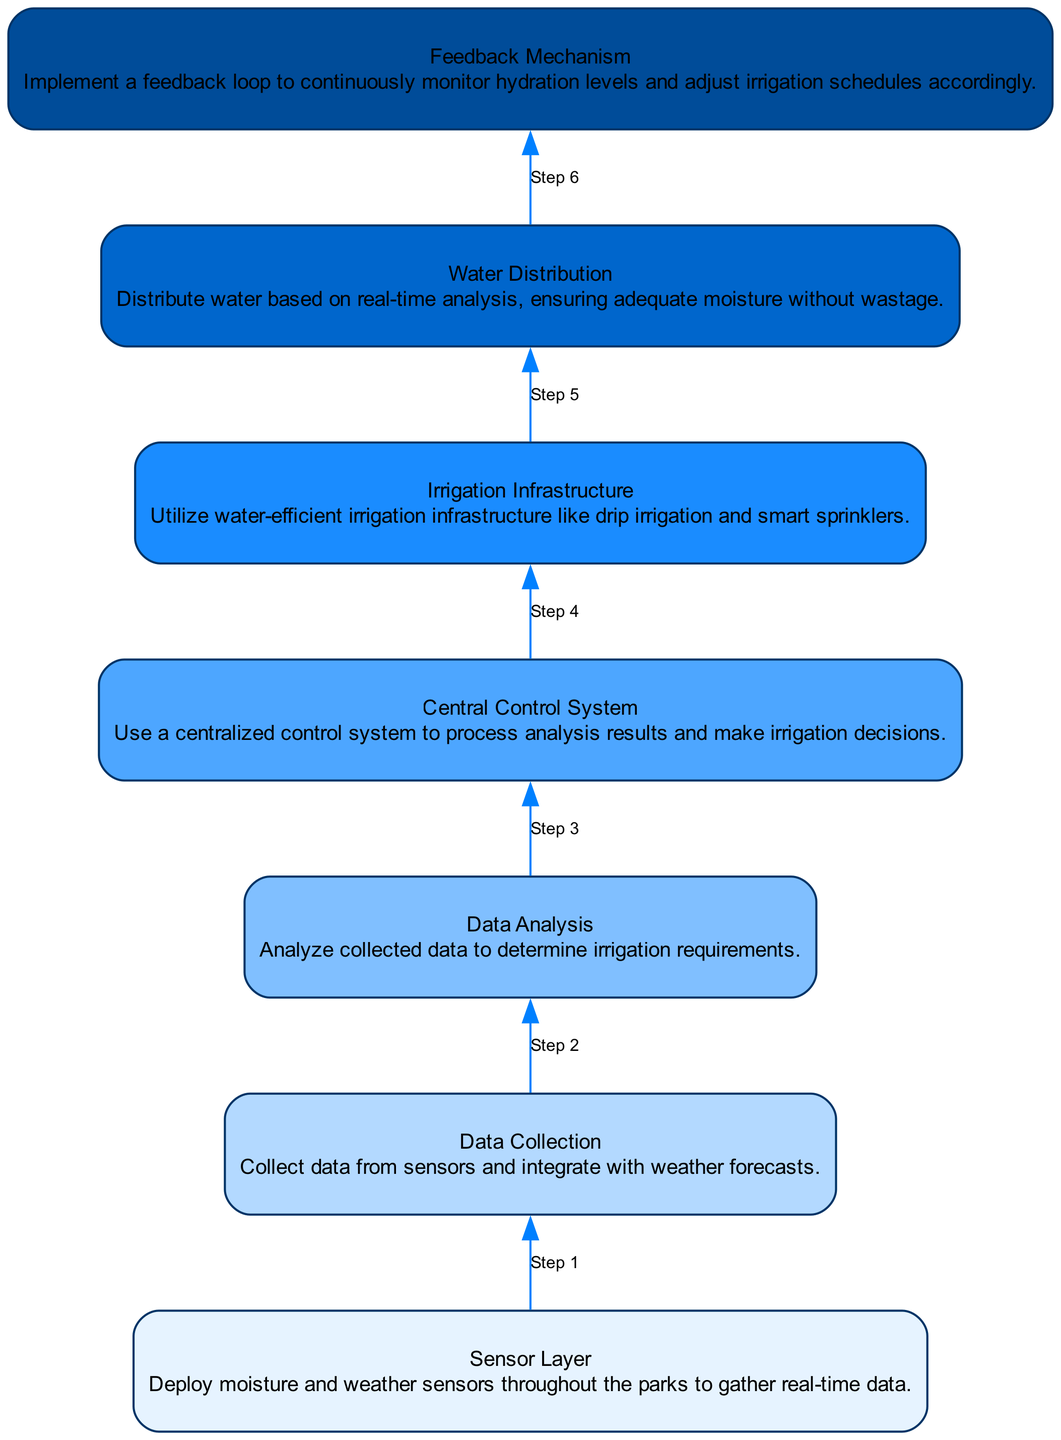What is the final step in the flow chart? The final step in the flow chart is the "Feedback Mechanism" which is positioned at the topmost part of the diagram.
Answer: Feedback Mechanism How many nodes are there in total? By counting all the defined elements in the data, there are seven nodes in total as represented in the diagram.
Answer: Seven Which step immediately precedes "Water Distribution"? The step immediately preceding "Water Distribution" is "Central Control System". It is directly connected in the flow diagram.
Answer: Central Control System What is the primary function of the "Sensor Layer"? The primary function of the "Sensor Layer" is to deploy moisture and weather sensors throughout the parks for real-time data gathering, as stated in the node description.
Answer: Deploy moisture and weather sensors Which steps involve data analysis? The steps that involve data analysis are "Data Collection" and "Data Analysis". The flow indicates a direct relationship between these two as data is collected first and then analyzed.
Answer: Data Collection, Data Analysis How many edges are there connecting the nodes? By tracing the connections between each node in the diagram, there are six edges that show the flow from the bottom node to the top node.
Answer: Six What role does the "Central Control System" play in the irrigation process? The "Central Control System" processes analysis results and makes irrigation decisions, as detailed in its description, showing it is crucial for decision-making in the process.
Answer: Processes analysis results Which components are responsible for real-time adjustments based on hydration levels? The "Feedback Mechanism" is responsible for continuously monitoring hydration levels and adjusting irrigation schedules accordingly, highlighting its role in making real-time adjustments.
Answer: Feedback Mechanism What type of irrigation infrastructure is mentioned in the diagram? The diagram mentions "water-efficient irrigation infrastructure like drip irrigation and smart sprinklers" as part of its components, showcasing a focus on efficiency.
Answer: Drip irrigation and smart sprinklers 